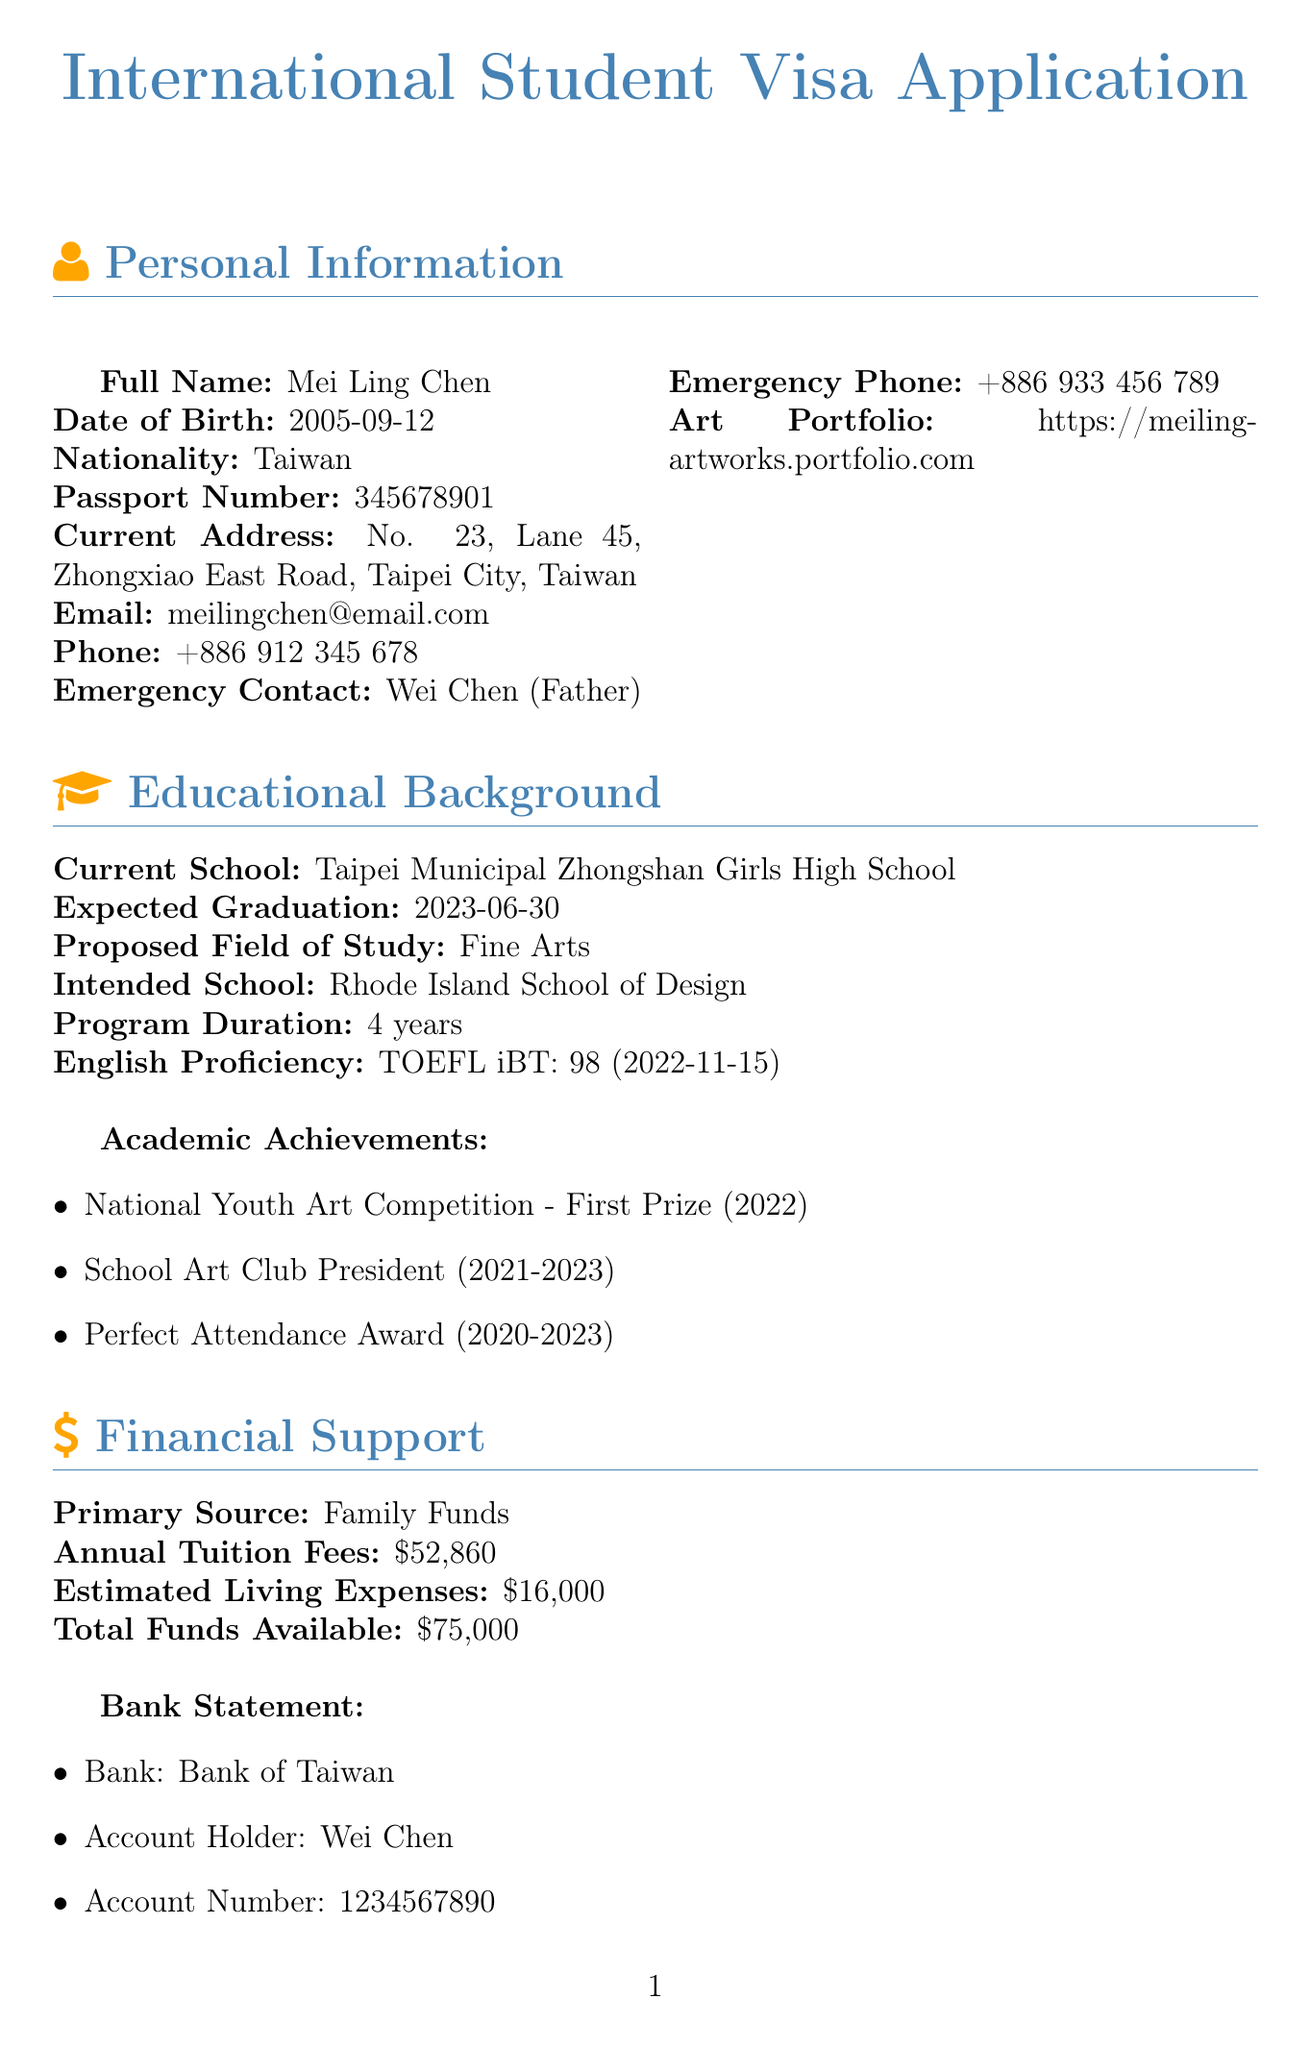What is the full name of the applicant? The applicant's full name is listed in the personal information section.
Answer: Mei Ling Chen When is the expected graduation date? The expected graduation date can be found in the educational background section.
Answer: 2023-06-30 What is the proposed field of study? The proposed field of study is mentioned under the educational background section.
Answer: Fine Arts What is the annual tuition fee? The annual tuition fee is noted in the financial support section.
Answer: $52,860 Who is the emergency contact? The emergency contact person's name and relationship are provided in the personal information section.
Answer: Wei Chen What is the total funds available? The total funds available can be retrieved from the financial support section of the document.
Answer: $75,000 What scholarship has been awarded? The scholarship name and amount are listed in the financial support section.
Answer: Taiwan Ministry of Education Overseas Study Scholarship What is the intention for studying abroad? The reason for studying abroad is stated in the additional information section.
Answer: To expand artistic horizons How long is the program duration? The program duration is specified in the educational background section.
Answer: 4 years What are the extracurricular interests? The extracurricular interests are detailed in the additional information section.
Answer: Painting, Digital illustration, Photography, Anime and manga club 